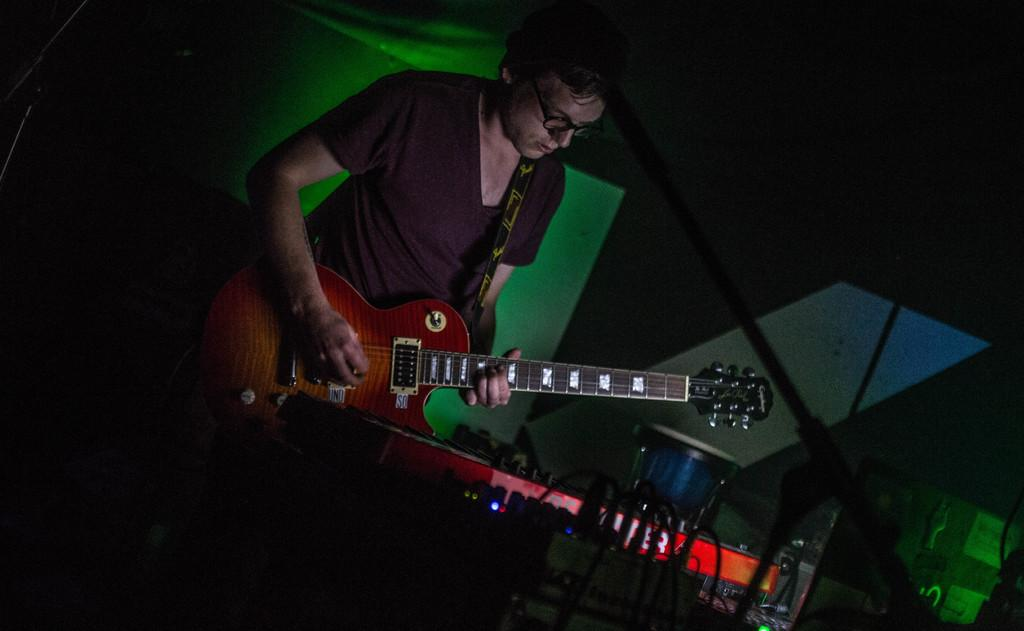Who is the main subject in the image? There is a man in the image. What is the man holding in the image? The man is holding a guitar. What object is in front of the man? There is a Casio in front of the man. What type of school is depicted in the image? There is no school depicted in the image; it features a man holding a guitar and a Casio in front of him. What type of army is shown in the image? There is no army present in the image; it features a man holding a guitar and a Casio in front of him. 